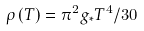Convert formula to latex. <formula><loc_0><loc_0><loc_500><loc_500>\rho \left ( T \right ) = \pi ^ { 2 } g _ { \ast } T ^ { 4 } / 3 0</formula> 